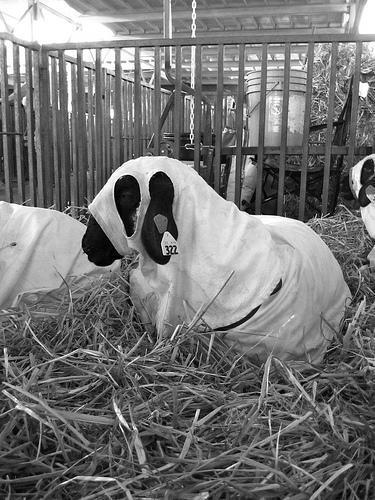How many chains are there?
Give a very brief answer. 1. 